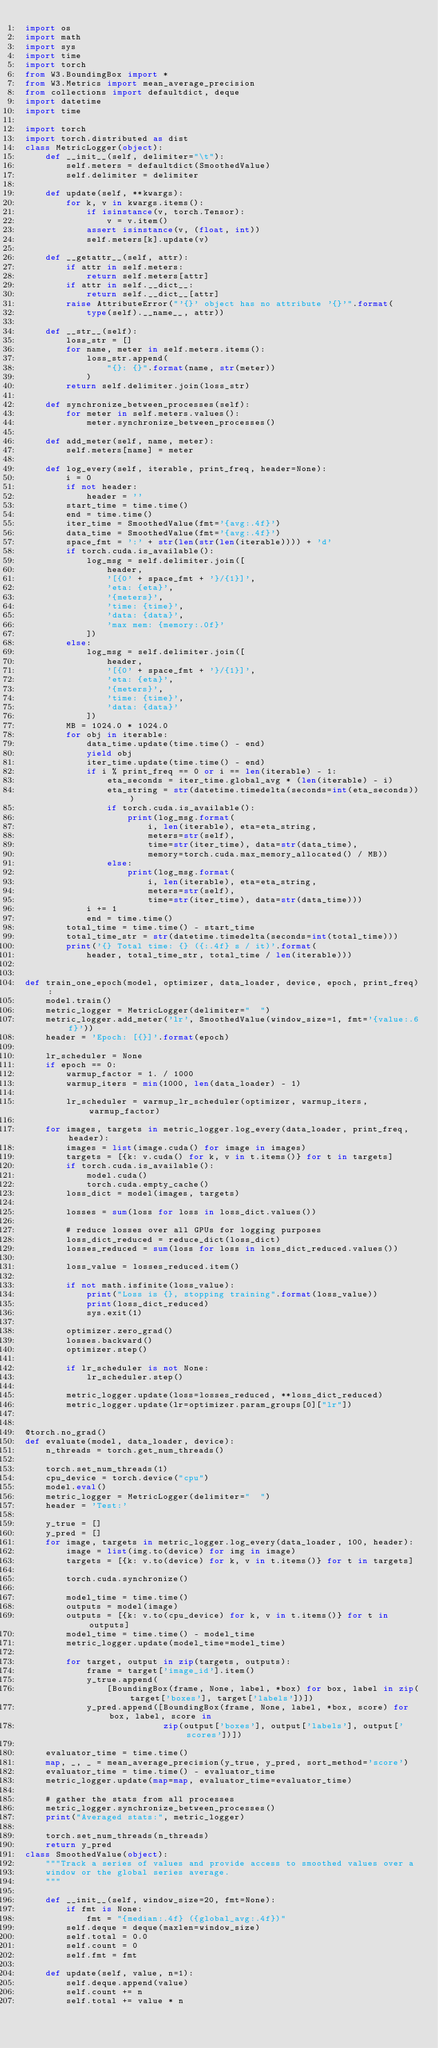<code> <loc_0><loc_0><loc_500><loc_500><_Python_>import os
import math
import sys
import time
import torch
from W3.BoundingBox import *
from W3.Metrics import mean_average_precision
from collections import defaultdict, deque
import datetime
import time

import torch
import torch.distributed as dist
class MetricLogger(object):
    def __init__(self, delimiter="\t"):
        self.meters = defaultdict(SmoothedValue)
        self.delimiter = delimiter

    def update(self, **kwargs):
        for k, v in kwargs.items():
            if isinstance(v, torch.Tensor):
                v = v.item()
            assert isinstance(v, (float, int))
            self.meters[k].update(v)

    def __getattr__(self, attr):
        if attr in self.meters:
            return self.meters[attr]
        if attr in self.__dict__:
            return self.__dict__[attr]
        raise AttributeError("'{}' object has no attribute '{}'".format(
            type(self).__name__, attr))

    def __str__(self):
        loss_str = []
        for name, meter in self.meters.items():
            loss_str.append(
                "{}: {}".format(name, str(meter))
            )
        return self.delimiter.join(loss_str)

    def synchronize_between_processes(self):
        for meter in self.meters.values():
            meter.synchronize_between_processes()

    def add_meter(self, name, meter):
        self.meters[name] = meter

    def log_every(self, iterable, print_freq, header=None):
        i = 0
        if not header:
            header = ''
        start_time = time.time()
        end = time.time()
        iter_time = SmoothedValue(fmt='{avg:.4f}')
        data_time = SmoothedValue(fmt='{avg:.4f}')
        space_fmt = ':' + str(len(str(len(iterable)))) + 'd'
        if torch.cuda.is_available():
            log_msg = self.delimiter.join([
                header,
                '[{0' + space_fmt + '}/{1}]',
                'eta: {eta}',
                '{meters}',
                'time: {time}',
                'data: {data}',
                'max mem: {memory:.0f}'
            ])
        else:
            log_msg = self.delimiter.join([
                header,
                '[{0' + space_fmt + '}/{1}]',
                'eta: {eta}',
                '{meters}',
                'time: {time}',
                'data: {data}'
            ])
        MB = 1024.0 * 1024.0
        for obj in iterable:
            data_time.update(time.time() - end)
            yield obj
            iter_time.update(time.time() - end)
            if i % print_freq == 0 or i == len(iterable) - 1:
                eta_seconds = iter_time.global_avg * (len(iterable) - i)
                eta_string = str(datetime.timedelta(seconds=int(eta_seconds)))
                if torch.cuda.is_available():
                    print(log_msg.format(
                        i, len(iterable), eta=eta_string,
                        meters=str(self),
                        time=str(iter_time), data=str(data_time),
                        memory=torch.cuda.max_memory_allocated() / MB))
                else:
                    print(log_msg.format(
                        i, len(iterable), eta=eta_string,
                        meters=str(self),
                        time=str(iter_time), data=str(data_time)))
            i += 1
            end = time.time()
        total_time = time.time() - start_time
        total_time_str = str(datetime.timedelta(seconds=int(total_time)))
        print('{} Total time: {} ({:.4f} s / it)'.format(
            header, total_time_str, total_time / len(iterable)))


def train_one_epoch(model, optimizer, data_loader, device, epoch, print_freq):
    model.train()
    metric_logger = MetricLogger(delimiter="  ")
    metric_logger.add_meter('lr', SmoothedValue(window_size=1, fmt='{value:.6f}'))
    header = 'Epoch: [{}]'.format(epoch)

    lr_scheduler = None
    if epoch == 0:
        warmup_factor = 1. / 1000
        warmup_iters = min(1000, len(data_loader) - 1)

        lr_scheduler = warmup_lr_scheduler(optimizer, warmup_iters, warmup_factor)

    for images, targets in metric_logger.log_every(data_loader, print_freq, header):
        images = list(image.cuda() for image in images)
        targets = [{k: v.cuda() for k, v in t.items()} for t in targets]
        if torch.cuda.is_available():
            model.cuda()
            torch.cuda.empty_cache()
        loss_dict = model(images, targets)

        losses = sum(loss for loss in loss_dict.values())

        # reduce losses over all GPUs for logging purposes
        loss_dict_reduced = reduce_dict(loss_dict)
        losses_reduced = sum(loss for loss in loss_dict_reduced.values())

        loss_value = losses_reduced.item()

        if not math.isfinite(loss_value):
            print("Loss is {}, stopping training".format(loss_value))
            print(loss_dict_reduced)
            sys.exit(1)

        optimizer.zero_grad()
        losses.backward()
        optimizer.step()

        if lr_scheduler is not None:
            lr_scheduler.step()

        metric_logger.update(loss=losses_reduced, **loss_dict_reduced)
        metric_logger.update(lr=optimizer.param_groups[0]["lr"])


@torch.no_grad()
def evaluate(model, data_loader, device):
    n_threads = torch.get_num_threads()

    torch.set_num_threads(1)
    cpu_device = torch.device("cpu")
    model.eval()
    metric_logger = MetricLogger(delimiter="  ")
    header = 'Test:'

    y_true = []
    y_pred = []
    for image, targets in metric_logger.log_every(data_loader, 100, header):
        image = list(img.to(device) for img in image)
        targets = [{k: v.to(device) for k, v in t.items()} for t in targets]

        torch.cuda.synchronize()

        model_time = time.time()
        outputs = model(image)
        outputs = [{k: v.to(cpu_device) for k, v in t.items()} for t in outputs]
        model_time = time.time() - model_time
        metric_logger.update(model_time=model_time)

        for target, output in zip(targets, outputs):
            frame = target['image_id'].item()
            y_true.append(
                [BoundingBox(frame, None, label, *box) for box, label in zip(target['boxes'], target['labels'])])
            y_pred.append([BoundingBox(frame, None, label, *box, score) for box, label, score in
                           zip(output['boxes'], output['labels'], output['scores'])])

    evaluator_time = time.time()
    map, _, _ = mean_average_precision(y_true, y_pred, sort_method='score')
    evaluator_time = time.time() - evaluator_time
    metric_logger.update(map=map, evaluator_time=evaluator_time)

    # gather the stats from all processes
    metric_logger.synchronize_between_processes()
    print("Averaged stats:", metric_logger)

    torch.set_num_threads(n_threads)
    return y_pred
class SmoothedValue(object):
    """Track a series of values and provide access to smoothed values over a
    window or the global series average.
    """

    def __init__(self, window_size=20, fmt=None):
        if fmt is None:
            fmt = "{median:.4f} ({global_avg:.4f})"
        self.deque = deque(maxlen=window_size)
        self.total = 0.0
        self.count = 0
        self.fmt = fmt

    def update(self, value, n=1):
        self.deque.append(value)
        self.count += n
        self.total += value * n
</code> 